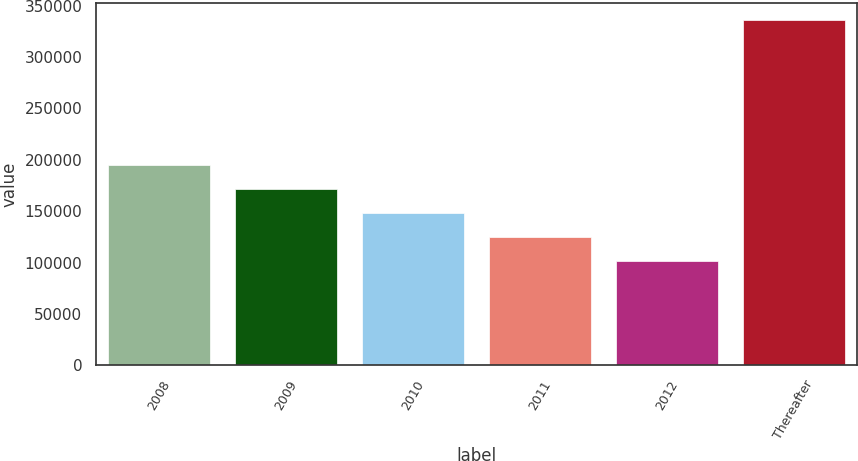<chart> <loc_0><loc_0><loc_500><loc_500><bar_chart><fcel>2008<fcel>2009<fcel>2010<fcel>2011<fcel>2012<fcel>Thereafter<nl><fcel>195073<fcel>171564<fcel>148054<fcel>124545<fcel>101035<fcel>336131<nl></chart> 